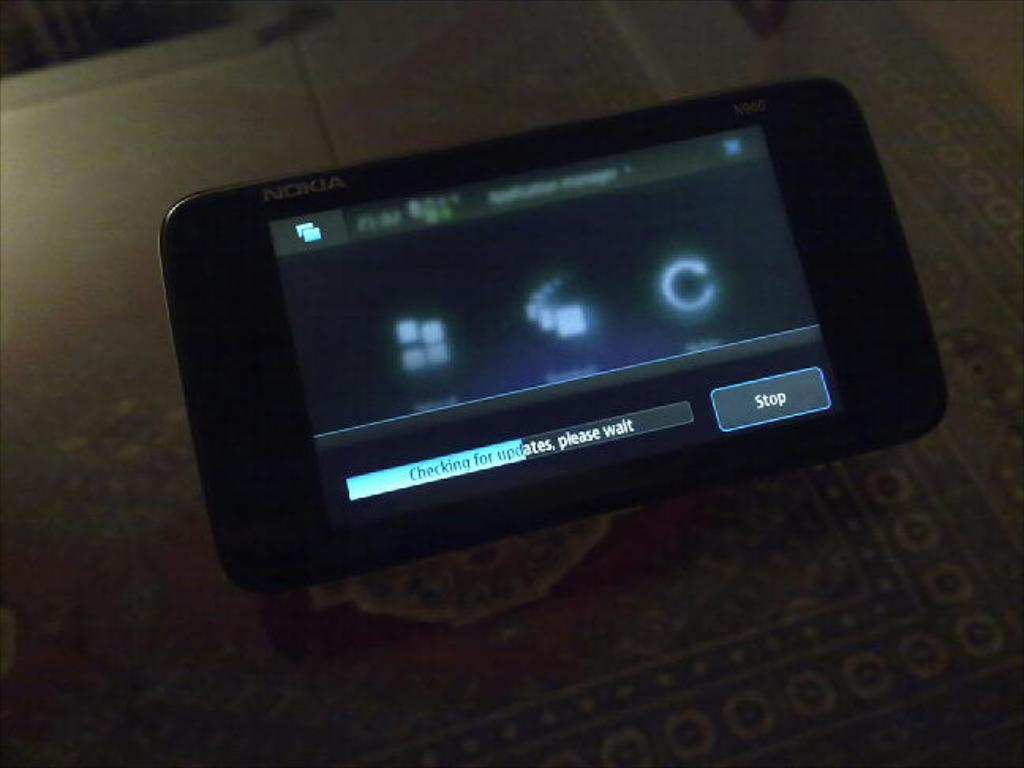What electronic device is visible in the image? There is a mobile phone in the image. Where is the mobile phone located in the image? The mobile phone is placed on a surface. What type of donkey can be seen interacting with the mobile phone in the image? There is no donkey present in the image, and therefore no such interaction can be observed. 